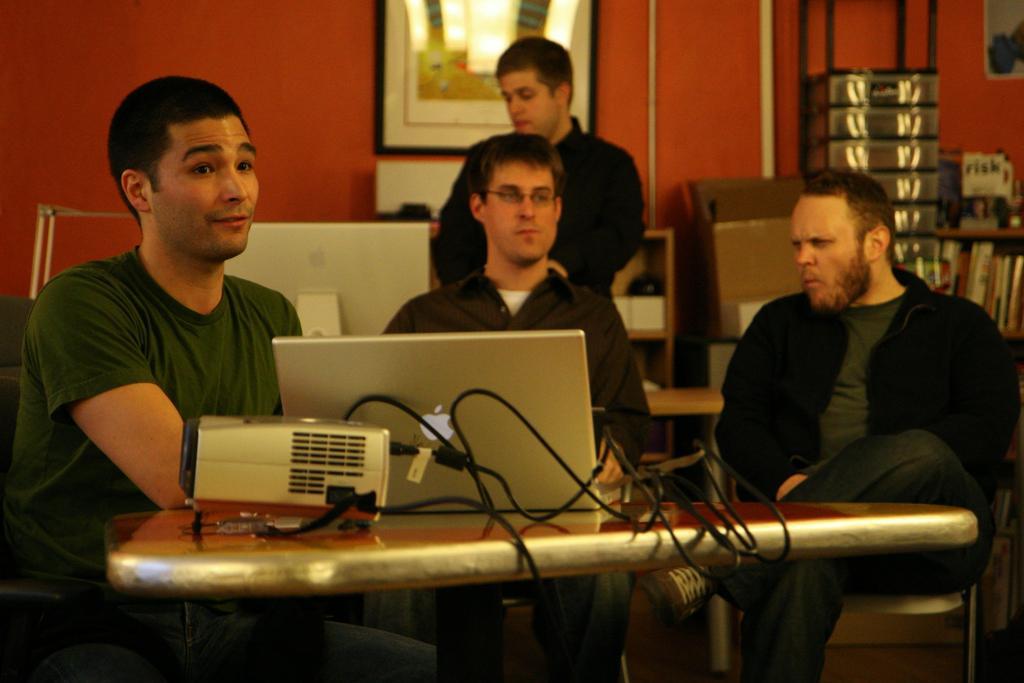How would you summarize this image in a sentence or two? In this picture we can see three men sitting on chairs and in front of them we can see a table with a laptop, device, cables on it and in the background we can see a man, monitor, boxes, books, frame on the wall, some objects. 